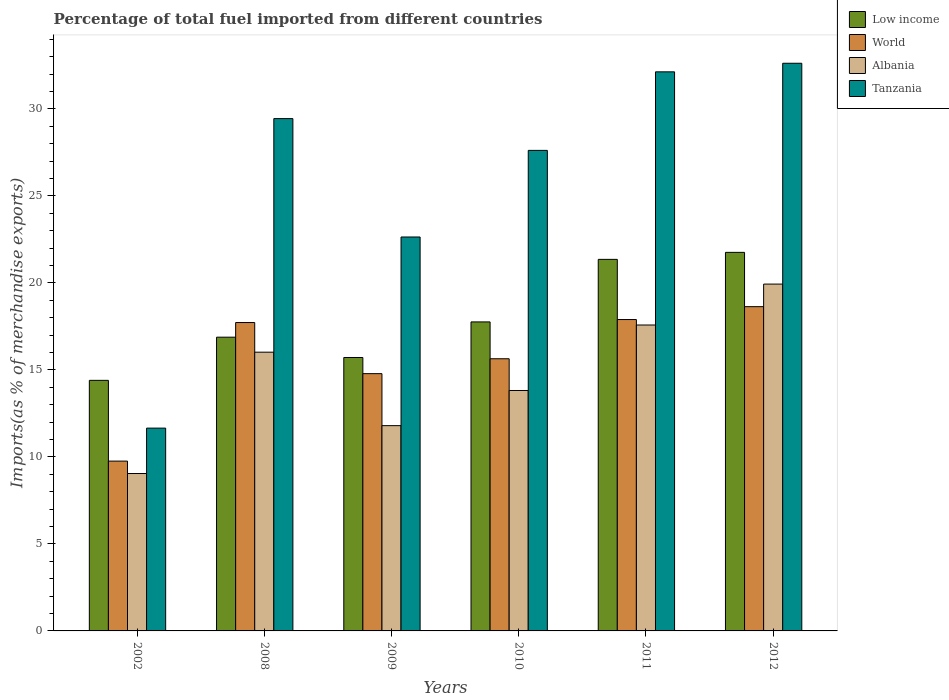How many groups of bars are there?
Your answer should be very brief. 6. In how many cases, is the number of bars for a given year not equal to the number of legend labels?
Your response must be concise. 0. What is the percentage of imports to different countries in Tanzania in 2012?
Offer a terse response. 32.63. Across all years, what is the maximum percentage of imports to different countries in Low income?
Your answer should be very brief. 21.76. Across all years, what is the minimum percentage of imports to different countries in Low income?
Make the answer very short. 14.4. In which year was the percentage of imports to different countries in Tanzania maximum?
Give a very brief answer. 2012. What is the total percentage of imports to different countries in Albania in the graph?
Provide a succinct answer. 88.2. What is the difference between the percentage of imports to different countries in Albania in 2002 and that in 2008?
Provide a short and direct response. -6.97. What is the difference between the percentage of imports to different countries in Tanzania in 2009 and the percentage of imports to different countries in Albania in 2002?
Keep it short and to the point. 13.6. What is the average percentage of imports to different countries in Low income per year?
Keep it short and to the point. 17.98. In the year 2002, what is the difference between the percentage of imports to different countries in Low income and percentage of imports to different countries in Albania?
Your response must be concise. 5.36. In how many years, is the percentage of imports to different countries in Albania greater than 27 %?
Your response must be concise. 0. What is the ratio of the percentage of imports to different countries in Tanzania in 2008 to that in 2009?
Offer a terse response. 1.3. Is the percentage of imports to different countries in Low income in 2002 less than that in 2008?
Provide a succinct answer. Yes. Is the difference between the percentage of imports to different countries in Low income in 2009 and 2010 greater than the difference between the percentage of imports to different countries in Albania in 2009 and 2010?
Ensure brevity in your answer.  No. What is the difference between the highest and the second highest percentage of imports to different countries in Low income?
Your response must be concise. 0.4. What is the difference between the highest and the lowest percentage of imports to different countries in Tanzania?
Give a very brief answer. 20.97. Is it the case that in every year, the sum of the percentage of imports to different countries in Low income and percentage of imports to different countries in Tanzania is greater than the sum of percentage of imports to different countries in Albania and percentage of imports to different countries in World?
Ensure brevity in your answer.  Yes. What does the 4th bar from the left in 2010 represents?
Your answer should be very brief. Tanzania. Is it the case that in every year, the sum of the percentage of imports to different countries in World and percentage of imports to different countries in Albania is greater than the percentage of imports to different countries in Low income?
Offer a terse response. Yes. How many years are there in the graph?
Give a very brief answer. 6. What is the difference between two consecutive major ticks on the Y-axis?
Give a very brief answer. 5. Are the values on the major ticks of Y-axis written in scientific E-notation?
Your answer should be very brief. No. Does the graph contain any zero values?
Offer a very short reply. No. Does the graph contain grids?
Give a very brief answer. No. How many legend labels are there?
Your answer should be very brief. 4. How are the legend labels stacked?
Ensure brevity in your answer.  Vertical. What is the title of the graph?
Provide a short and direct response. Percentage of total fuel imported from different countries. Does "World" appear as one of the legend labels in the graph?
Your response must be concise. Yes. What is the label or title of the Y-axis?
Your answer should be compact. Imports(as % of merchandise exports). What is the Imports(as % of merchandise exports) in Low income in 2002?
Ensure brevity in your answer.  14.4. What is the Imports(as % of merchandise exports) of World in 2002?
Your answer should be compact. 9.76. What is the Imports(as % of merchandise exports) of Albania in 2002?
Provide a succinct answer. 9.05. What is the Imports(as % of merchandise exports) in Tanzania in 2002?
Give a very brief answer. 11.66. What is the Imports(as % of merchandise exports) in Low income in 2008?
Your answer should be compact. 16.88. What is the Imports(as % of merchandise exports) in World in 2008?
Your response must be concise. 17.72. What is the Imports(as % of merchandise exports) of Albania in 2008?
Your answer should be very brief. 16.02. What is the Imports(as % of merchandise exports) of Tanzania in 2008?
Offer a terse response. 29.45. What is the Imports(as % of merchandise exports) in Low income in 2009?
Keep it short and to the point. 15.72. What is the Imports(as % of merchandise exports) in World in 2009?
Give a very brief answer. 14.79. What is the Imports(as % of merchandise exports) in Albania in 2009?
Your answer should be compact. 11.8. What is the Imports(as % of merchandise exports) in Tanzania in 2009?
Your response must be concise. 22.64. What is the Imports(as % of merchandise exports) in Low income in 2010?
Your response must be concise. 17.76. What is the Imports(as % of merchandise exports) of World in 2010?
Your answer should be compact. 15.64. What is the Imports(as % of merchandise exports) of Albania in 2010?
Provide a succinct answer. 13.82. What is the Imports(as % of merchandise exports) of Tanzania in 2010?
Your response must be concise. 27.62. What is the Imports(as % of merchandise exports) of Low income in 2011?
Keep it short and to the point. 21.36. What is the Imports(as % of merchandise exports) of World in 2011?
Offer a very short reply. 17.9. What is the Imports(as % of merchandise exports) in Albania in 2011?
Ensure brevity in your answer.  17.58. What is the Imports(as % of merchandise exports) of Tanzania in 2011?
Your answer should be very brief. 32.13. What is the Imports(as % of merchandise exports) in Low income in 2012?
Offer a terse response. 21.76. What is the Imports(as % of merchandise exports) in World in 2012?
Keep it short and to the point. 18.64. What is the Imports(as % of merchandise exports) in Albania in 2012?
Provide a succinct answer. 19.93. What is the Imports(as % of merchandise exports) in Tanzania in 2012?
Your response must be concise. 32.63. Across all years, what is the maximum Imports(as % of merchandise exports) of Low income?
Your response must be concise. 21.76. Across all years, what is the maximum Imports(as % of merchandise exports) in World?
Your answer should be very brief. 18.64. Across all years, what is the maximum Imports(as % of merchandise exports) of Albania?
Keep it short and to the point. 19.93. Across all years, what is the maximum Imports(as % of merchandise exports) of Tanzania?
Your answer should be very brief. 32.63. Across all years, what is the minimum Imports(as % of merchandise exports) of Low income?
Ensure brevity in your answer.  14.4. Across all years, what is the minimum Imports(as % of merchandise exports) of World?
Offer a terse response. 9.76. Across all years, what is the minimum Imports(as % of merchandise exports) in Albania?
Offer a very short reply. 9.05. Across all years, what is the minimum Imports(as % of merchandise exports) of Tanzania?
Provide a succinct answer. 11.66. What is the total Imports(as % of merchandise exports) of Low income in the graph?
Your response must be concise. 107.87. What is the total Imports(as % of merchandise exports) of World in the graph?
Keep it short and to the point. 94.45. What is the total Imports(as % of merchandise exports) in Albania in the graph?
Offer a terse response. 88.2. What is the total Imports(as % of merchandise exports) in Tanzania in the graph?
Your answer should be compact. 156.12. What is the difference between the Imports(as % of merchandise exports) of Low income in 2002 and that in 2008?
Provide a succinct answer. -2.48. What is the difference between the Imports(as % of merchandise exports) in World in 2002 and that in 2008?
Offer a terse response. -7.96. What is the difference between the Imports(as % of merchandise exports) in Albania in 2002 and that in 2008?
Ensure brevity in your answer.  -6.97. What is the difference between the Imports(as % of merchandise exports) of Tanzania in 2002 and that in 2008?
Keep it short and to the point. -17.79. What is the difference between the Imports(as % of merchandise exports) in Low income in 2002 and that in 2009?
Your response must be concise. -1.31. What is the difference between the Imports(as % of merchandise exports) of World in 2002 and that in 2009?
Your answer should be compact. -5.03. What is the difference between the Imports(as % of merchandise exports) in Albania in 2002 and that in 2009?
Your answer should be very brief. -2.75. What is the difference between the Imports(as % of merchandise exports) of Tanzania in 2002 and that in 2009?
Provide a succinct answer. -10.98. What is the difference between the Imports(as % of merchandise exports) in Low income in 2002 and that in 2010?
Your answer should be very brief. -3.36. What is the difference between the Imports(as % of merchandise exports) in World in 2002 and that in 2010?
Provide a succinct answer. -5.88. What is the difference between the Imports(as % of merchandise exports) in Albania in 2002 and that in 2010?
Offer a terse response. -4.77. What is the difference between the Imports(as % of merchandise exports) of Tanzania in 2002 and that in 2010?
Ensure brevity in your answer.  -15.96. What is the difference between the Imports(as % of merchandise exports) of Low income in 2002 and that in 2011?
Provide a succinct answer. -6.95. What is the difference between the Imports(as % of merchandise exports) in World in 2002 and that in 2011?
Your answer should be compact. -8.14. What is the difference between the Imports(as % of merchandise exports) of Albania in 2002 and that in 2011?
Make the answer very short. -8.54. What is the difference between the Imports(as % of merchandise exports) of Tanzania in 2002 and that in 2011?
Your answer should be very brief. -20.48. What is the difference between the Imports(as % of merchandise exports) in Low income in 2002 and that in 2012?
Your answer should be compact. -7.36. What is the difference between the Imports(as % of merchandise exports) in World in 2002 and that in 2012?
Provide a short and direct response. -8.88. What is the difference between the Imports(as % of merchandise exports) in Albania in 2002 and that in 2012?
Keep it short and to the point. -10.89. What is the difference between the Imports(as % of merchandise exports) of Tanzania in 2002 and that in 2012?
Provide a short and direct response. -20.97. What is the difference between the Imports(as % of merchandise exports) in Low income in 2008 and that in 2009?
Provide a short and direct response. 1.17. What is the difference between the Imports(as % of merchandise exports) of World in 2008 and that in 2009?
Give a very brief answer. 2.94. What is the difference between the Imports(as % of merchandise exports) in Albania in 2008 and that in 2009?
Keep it short and to the point. 4.22. What is the difference between the Imports(as % of merchandise exports) of Tanzania in 2008 and that in 2009?
Make the answer very short. 6.8. What is the difference between the Imports(as % of merchandise exports) of Low income in 2008 and that in 2010?
Make the answer very short. -0.88. What is the difference between the Imports(as % of merchandise exports) of World in 2008 and that in 2010?
Keep it short and to the point. 2.08. What is the difference between the Imports(as % of merchandise exports) of Albania in 2008 and that in 2010?
Offer a terse response. 2.2. What is the difference between the Imports(as % of merchandise exports) in Tanzania in 2008 and that in 2010?
Your response must be concise. 1.83. What is the difference between the Imports(as % of merchandise exports) of Low income in 2008 and that in 2011?
Your answer should be very brief. -4.47. What is the difference between the Imports(as % of merchandise exports) of World in 2008 and that in 2011?
Provide a succinct answer. -0.17. What is the difference between the Imports(as % of merchandise exports) of Albania in 2008 and that in 2011?
Your response must be concise. -1.56. What is the difference between the Imports(as % of merchandise exports) in Tanzania in 2008 and that in 2011?
Provide a short and direct response. -2.69. What is the difference between the Imports(as % of merchandise exports) of Low income in 2008 and that in 2012?
Give a very brief answer. -4.88. What is the difference between the Imports(as % of merchandise exports) of World in 2008 and that in 2012?
Offer a very short reply. -0.91. What is the difference between the Imports(as % of merchandise exports) in Albania in 2008 and that in 2012?
Provide a short and direct response. -3.91. What is the difference between the Imports(as % of merchandise exports) of Tanzania in 2008 and that in 2012?
Offer a very short reply. -3.18. What is the difference between the Imports(as % of merchandise exports) in Low income in 2009 and that in 2010?
Ensure brevity in your answer.  -2.04. What is the difference between the Imports(as % of merchandise exports) of World in 2009 and that in 2010?
Your response must be concise. -0.86. What is the difference between the Imports(as % of merchandise exports) in Albania in 2009 and that in 2010?
Give a very brief answer. -2.02. What is the difference between the Imports(as % of merchandise exports) in Tanzania in 2009 and that in 2010?
Provide a succinct answer. -4.98. What is the difference between the Imports(as % of merchandise exports) of Low income in 2009 and that in 2011?
Provide a short and direct response. -5.64. What is the difference between the Imports(as % of merchandise exports) in World in 2009 and that in 2011?
Keep it short and to the point. -3.11. What is the difference between the Imports(as % of merchandise exports) in Albania in 2009 and that in 2011?
Your answer should be compact. -5.78. What is the difference between the Imports(as % of merchandise exports) in Tanzania in 2009 and that in 2011?
Your answer should be compact. -9.49. What is the difference between the Imports(as % of merchandise exports) in Low income in 2009 and that in 2012?
Provide a short and direct response. -6.04. What is the difference between the Imports(as % of merchandise exports) in World in 2009 and that in 2012?
Ensure brevity in your answer.  -3.85. What is the difference between the Imports(as % of merchandise exports) in Albania in 2009 and that in 2012?
Provide a short and direct response. -8.14. What is the difference between the Imports(as % of merchandise exports) in Tanzania in 2009 and that in 2012?
Give a very brief answer. -9.99. What is the difference between the Imports(as % of merchandise exports) in Low income in 2010 and that in 2011?
Make the answer very short. -3.59. What is the difference between the Imports(as % of merchandise exports) in World in 2010 and that in 2011?
Make the answer very short. -2.25. What is the difference between the Imports(as % of merchandise exports) of Albania in 2010 and that in 2011?
Your response must be concise. -3.76. What is the difference between the Imports(as % of merchandise exports) in Tanzania in 2010 and that in 2011?
Ensure brevity in your answer.  -4.51. What is the difference between the Imports(as % of merchandise exports) in Low income in 2010 and that in 2012?
Offer a very short reply. -4. What is the difference between the Imports(as % of merchandise exports) of World in 2010 and that in 2012?
Ensure brevity in your answer.  -2.99. What is the difference between the Imports(as % of merchandise exports) of Albania in 2010 and that in 2012?
Your answer should be compact. -6.12. What is the difference between the Imports(as % of merchandise exports) in Tanzania in 2010 and that in 2012?
Give a very brief answer. -5.01. What is the difference between the Imports(as % of merchandise exports) of Low income in 2011 and that in 2012?
Keep it short and to the point. -0.4. What is the difference between the Imports(as % of merchandise exports) in World in 2011 and that in 2012?
Provide a short and direct response. -0.74. What is the difference between the Imports(as % of merchandise exports) in Albania in 2011 and that in 2012?
Keep it short and to the point. -2.35. What is the difference between the Imports(as % of merchandise exports) of Tanzania in 2011 and that in 2012?
Your answer should be very brief. -0.49. What is the difference between the Imports(as % of merchandise exports) of Low income in 2002 and the Imports(as % of merchandise exports) of World in 2008?
Provide a succinct answer. -3.32. What is the difference between the Imports(as % of merchandise exports) of Low income in 2002 and the Imports(as % of merchandise exports) of Albania in 2008?
Your answer should be compact. -1.62. What is the difference between the Imports(as % of merchandise exports) in Low income in 2002 and the Imports(as % of merchandise exports) in Tanzania in 2008?
Your answer should be very brief. -15.04. What is the difference between the Imports(as % of merchandise exports) of World in 2002 and the Imports(as % of merchandise exports) of Albania in 2008?
Provide a succinct answer. -6.26. What is the difference between the Imports(as % of merchandise exports) of World in 2002 and the Imports(as % of merchandise exports) of Tanzania in 2008?
Make the answer very short. -19.69. What is the difference between the Imports(as % of merchandise exports) in Albania in 2002 and the Imports(as % of merchandise exports) in Tanzania in 2008?
Offer a very short reply. -20.4. What is the difference between the Imports(as % of merchandise exports) in Low income in 2002 and the Imports(as % of merchandise exports) in World in 2009?
Make the answer very short. -0.38. What is the difference between the Imports(as % of merchandise exports) in Low income in 2002 and the Imports(as % of merchandise exports) in Albania in 2009?
Make the answer very short. 2.6. What is the difference between the Imports(as % of merchandise exports) of Low income in 2002 and the Imports(as % of merchandise exports) of Tanzania in 2009?
Make the answer very short. -8.24. What is the difference between the Imports(as % of merchandise exports) in World in 2002 and the Imports(as % of merchandise exports) in Albania in 2009?
Ensure brevity in your answer.  -2.04. What is the difference between the Imports(as % of merchandise exports) of World in 2002 and the Imports(as % of merchandise exports) of Tanzania in 2009?
Give a very brief answer. -12.88. What is the difference between the Imports(as % of merchandise exports) of Albania in 2002 and the Imports(as % of merchandise exports) of Tanzania in 2009?
Provide a succinct answer. -13.6. What is the difference between the Imports(as % of merchandise exports) of Low income in 2002 and the Imports(as % of merchandise exports) of World in 2010?
Provide a succinct answer. -1.24. What is the difference between the Imports(as % of merchandise exports) in Low income in 2002 and the Imports(as % of merchandise exports) in Albania in 2010?
Your answer should be very brief. 0.58. What is the difference between the Imports(as % of merchandise exports) in Low income in 2002 and the Imports(as % of merchandise exports) in Tanzania in 2010?
Make the answer very short. -13.22. What is the difference between the Imports(as % of merchandise exports) in World in 2002 and the Imports(as % of merchandise exports) in Albania in 2010?
Your response must be concise. -4.06. What is the difference between the Imports(as % of merchandise exports) in World in 2002 and the Imports(as % of merchandise exports) in Tanzania in 2010?
Make the answer very short. -17.86. What is the difference between the Imports(as % of merchandise exports) of Albania in 2002 and the Imports(as % of merchandise exports) of Tanzania in 2010?
Provide a succinct answer. -18.57. What is the difference between the Imports(as % of merchandise exports) in Low income in 2002 and the Imports(as % of merchandise exports) in World in 2011?
Offer a very short reply. -3.5. What is the difference between the Imports(as % of merchandise exports) of Low income in 2002 and the Imports(as % of merchandise exports) of Albania in 2011?
Offer a very short reply. -3.18. What is the difference between the Imports(as % of merchandise exports) in Low income in 2002 and the Imports(as % of merchandise exports) in Tanzania in 2011?
Ensure brevity in your answer.  -17.73. What is the difference between the Imports(as % of merchandise exports) of World in 2002 and the Imports(as % of merchandise exports) of Albania in 2011?
Offer a very short reply. -7.82. What is the difference between the Imports(as % of merchandise exports) of World in 2002 and the Imports(as % of merchandise exports) of Tanzania in 2011?
Make the answer very short. -22.37. What is the difference between the Imports(as % of merchandise exports) of Albania in 2002 and the Imports(as % of merchandise exports) of Tanzania in 2011?
Give a very brief answer. -23.09. What is the difference between the Imports(as % of merchandise exports) in Low income in 2002 and the Imports(as % of merchandise exports) in World in 2012?
Keep it short and to the point. -4.24. What is the difference between the Imports(as % of merchandise exports) of Low income in 2002 and the Imports(as % of merchandise exports) of Albania in 2012?
Provide a succinct answer. -5.53. What is the difference between the Imports(as % of merchandise exports) of Low income in 2002 and the Imports(as % of merchandise exports) of Tanzania in 2012?
Make the answer very short. -18.23. What is the difference between the Imports(as % of merchandise exports) in World in 2002 and the Imports(as % of merchandise exports) in Albania in 2012?
Ensure brevity in your answer.  -10.17. What is the difference between the Imports(as % of merchandise exports) of World in 2002 and the Imports(as % of merchandise exports) of Tanzania in 2012?
Provide a succinct answer. -22.87. What is the difference between the Imports(as % of merchandise exports) of Albania in 2002 and the Imports(as % of merchandise exports) of Tanzania in 2012?
Offer a terse response. -23.58. What is the difference between the Imports(as % of merchandise exports) in Low income in 2008 and the Imports(as % of merchandise exports) in World in 2009?
Provide a short and direct response. 2.1. What is the difference between the Imports(as % of merchandise exports) in Low income in 2008 and the Imports(as % of merchandise exports) in Albania in 2009?
Your answer should be very brief. 5.08. What is the difference between the Imports(as % of merchandise exports) of Low income in 2008 and the Imports(as % of merchandise exports) of Tanzania in 2009?
Provide a succinct answer. -5.76. What is the difference between the Imports(as % of merchandise exports) in World in 2008 and the Imports(as % of merchandise exports) in Albania in 2009?
Give a very brief answer. 5.93. What is the difference between the Imports(as % of merchandise exports) in World in 2008 and the Imports(as % of merchandise exports) in Tanzania in 2009?
Your response must be concise. -4.92. What is the difference between the Imports(as % of merchandise exports) in Albania in 2008 and the Imports(as % of merchandise exports) in Tanzania in 2009?
Your response must be concise. -6.62. What is the difference between the Imports(as % of merchandise exports) in Low income in 2008 and the Imports(as % of merchandise exports) in World in 2010?
Offer a very short reply. 1.24. What is the difference between the Imports(as % of merchandise exports) of Low income in 2008 and the Imports(as % of merchandise exports) of Albania in 2010?
Your answer should be very brief. 3.06. What is the difference between the Imports(as % of merchandise exports) of Low income in 2008 and the Imports(as % of merchandise exports) of Tanzania in 2010?
Offer a terse response. -10.74. What is the difference between the Imports(as % of merchandise exports) of World in 2008 and the Imports(as % of merchandise exports) of Albania in 2010?
Provide a succinct answer. 3.91. What is the difference between the Imports(as % of merchandise exports) of World in 2008 and the Imports(as % of merchandise exports) of Tanzania in 2010?
Keep it short and to the point. -9.9. What is the difference between the Imports(as % of merchandise exports) in Albania in 2008 and the Imports(as % of merchandise exports) in Tanzania in 2010?
Ensure brevity in your answer.  -11.6. What is the difference between the Imports(as % of merchandise exports) in Low income in 2008 and the Imports(as % of merchandise exports) in World in 2011?
Your response must be concise. -1.01. What is the difference between the Imports(as % of merchandise exports) in Low income in 2008 and the Imports(as % of merchandise exports) in Albania in 2011?
Offer a terse response. -0.7. What is the difference between the Imports(as % of merchandise exports) of Low income in 2008 and the Imports(as % of merchandise exports) of Tanzania in 2011?
Your answer should be compact. -15.25. What is the difference between the Imports(as % of merchandise exports) of World in 2008 and the Imports(as % of merchandise exports) of Albania in 2011?
Make the answer very short. 0.14. What is the difference between the Imports(as % of merchandise exports) in World in 2008 and the Imports(as % of merchandise exports) in Tanzania in 2011?
Your answer should be compact. -14.41. What is the difference between the Imports(as % of merchandise exports) of Albania in 2008 and the Imports(as % of merchandise exports) of Tanzania in 2011?
Provide a succinct answer. -16.11. What is the difference between the Imports(as % of merchandise exports) in Low income in 2008 and the Imports(as % of merchandise exports) in World in 2012?
Ensure brevity in your answer.  -1.75. What is the difference between the Imports(as % of merchandise exports) of Low income in 2008 and the Imports(as % of merchandise exports) of Albania in 2012?
Your answer should be compact. -3.05. What is the difference between the Imports(as % of merchandise exports) of Low income in 2008 and the Imports(as % of merchandise exports) of Tanzania in 2012?
Provide a short and direct response. -15.74. What is the difference between the Imports(as % of merchandise exports) in World in 2008 and the Imports(as % of merchandise exports) in Albania in 2012?
Give a very brief answer. -2.21. What is the difference between the Imports(as % of merchandise exports) of World in 2008 and the Imports(as % of merchandise exports) of Tanzania in 2012?
Offer a terse response. -14.9. What is the difference between the Imports(as % of merchandise exports) of Albania in 2008 and the Imports(as % of merchandise exports) of Tanzania in 2012?
Your answer should be compact. -16.61. What is the difference between the Imports(as % of merchandise exports) of Low income in 2009 and the Imports(as % of merchandise exports) of World in 2010?
Your answer should be compact. 0.07. What is the difference between the Imports(as % of merchandise exports) of Low income in 2009 and the Imports(as % of merchandise exports) of Albania in 2010?
Make the answer very short. 1.9. What is the difference between the Imports(as % of merchandise exports) of Low income in 2009 and the Imports(as % of merchandise exports) of Tanzania in 2010?
Your answer should be compact. -11.9. What is the difference between the Imports(as % of merchandise exports) in World in 2009 and the Imports(as % of merchandise exports) in Albania in 2010?
Your answer should be compact. 0.97. What is the difference between the Imports(as % of merchandise exports) of World in 2009 and the Imports(as % of merchandise exports) of Tanzania in 2010?
Offer a terse response. -12.83. What is the difference between the Imports(as % of merchandise exports) of Albania in 2009 and the Imports(as % of merchandise exports) of Tanzania in 2010?
Provide a succinct answer. -15.82. What is the difference between the Imports(as % of merchandise exports) in Low income in 2009 and the Imports(as % of merchandise exports) in World in 2011?
Offer a terse response. -2.18. What is the difference between the Imports(as % of merchandise exports) in Low income in 2009 and the Imports(as % of merchandise exports) in Albania in 2011?
Your answer should be compact. -1.87. What is the difference between the Imports(as % of merchandise exports) in Low income in 2009 and the Imports(as % of merchandise exports) in Tanzania in 2011?
Provide a succinct answer. -16.42. What is the difference between the Imports(as % of merchandise exports) in World in 2009 and the Imports(as % of merchandise exports) in Albania in 2011?
Provide a succinct answer. -2.8. What is the difference between the Imports(as % of merchandise exports) in World in 2009 and the Imports(as % of merchandise exports) in Tanzania in 2011?
Keep it short and to the point. -17.35. What is the difference between the Imports(as % of merchandise exports) of Albania in 2009 and the Imports(as % of merchandise exports) of Tanzania in 2011?
Make the answer very short. -20.34. What is the difference between the Imports(as % of merchandise exports) of Low income in 2009 and the Imports(as % of merchandise exports) of World in 2012?
Give a very brief answer. -2.92. What is the difference between the Imports(as % of merchandise exports) of Low income in 2009 and the Imports(as % of merchandise exports) of Albania in 2012?
Your response must be concise. -4.22. What is the difference between the Imports(as % of merchandise exports) in Low income in 2009 and the Imports(as % of merchandise exports) in Tanzania in 2012?
Provide a succinct answer. -16.91. What is the difference between the Imports(as % of merchandise exports) in World in 2009 and the Imports(as % of merchandise exports) in Albania in 2012?
Offer a terse response. -5.15. What is the difference between the Imports(as % of merchandise exports) of World in 2009 and the Imports(as % of merchandise exports) of Tanzania in 2012?
Make the answer very short. -17.84. What is the difference between the Imports(as % of merchandise exports) in Albania in 2009 and the Imports(as % of merchandise exports) in Tanzania in 2012?
Provide a short and direct response. -20.83. What is the difference between the Imports(as % of merchandise exports) in Low income in 2010 and the Imports(as % of merchandise exports) in World in 2011?
Offer a very short reply. -0.14. What is the difference between the Imports(as % of merchandise exports) in Low income in 2010 and the Imports(as % of merchandise exports) in Albania in 2011?
Make the answer very short. 0.18. What is the difference between the Imports(as % of merchandise exports) in Low income in 2010 and the Imports(as % of merchandise exports) in Tanzania in 2011?
Provide a short and direct response. -14.37. What is the difference between the Imports(as % of merchandise exports) in World in 2010 and the Imports(as % of merchandise exports) in Albania in 2011?
Make the answer very short. -1.94. What is the difference between the Imports(as % of merchandise exports) in World in 2010 and the Imports(as % of merchandise exports) in Tanzania in 2011?
Provide a short and direct response. -16.49. What is the difference between the Imports(as % of merchandise exports) in Albania in 2010 and the Imports(as % of merchandise exports) in Tanzania in 2011?
Give a very brief answer. -18.31. What is the difference between the Imports(as % of merchandise exports) in Low income in 2010 and the Imports(as % of merchandise exports) in World in 2012?
Offer a terse response. -0.88. What is the difference between the Imports(as % of merchandise exports) of Low income in 2010 and the Imports(as % of merchandise exports) of Albania in 2012?
Provide a short and direct response. -2.17. What is the difference between the Imports(as % of merchandise exports) in Low income in 2010 and the Imports(as % of merchandise exports) in Tanzania in 2012?
Keep it short and to the point. -14.87. What is the difference between the Imports(as % of merchandise exports) in World in 2010 and the Imports(as % of merchandise exports) in Albania in 2012?
Your response must be concise. -4.29. What is the difference between the Imports(as % of merchandise exports) in World in 2010 and the Imports(as % of merchandise exports) in Tanzania in 2012?
Ensure brevity in your answer.  -16.98. What is the difference between the Imports(as % of merchandise exports) of Albania in 2010 and the Imports(as % of merchandise exports) of Tanzania in 2012?
Make the answer very short. -18.81. What is the difference between the Imports(as % of merchandise exports) of Low income in 2011 and the Imports(as % of merchandise exports) of World in 2012?
Make the answer very short. 2.72. What is the difference between the Imports(as % of merchandise exports) of Low income in 2011 and the Imports(as % of merchandise exports) of Albania in 2012?
Offer a terse response. 1.42. What is the difference between the Imports(as % of merchandise exports) of Low income in 2011 and the Imports(as % of merchandise exports) of Tanzania in 2012?
Offer a terse response. -11.27. What is the difference between the Imports(as % of merchandise exports) in World in 2011 and the Imports(as % of merchandise exports) in Albania in 2012?
Your response must be concise. -2.04. What is the difference between the Imports(as % of merchandise exports) in World in 2011 and the Imports(as % of merchandise exports) in Tanzania in 2012?
Give a very brief answer. -14.73. What is the difference between the Imports(as % of merchandise exports) of Albania in 2011 and the Imports(as % of merchandise exports) of Tanzania in 2012?
Give a very brief answer. -15.04. What is the average Imports(as % of merchandise exports) of Low income per year?
Make the answer very short. 17.98. What is the average Imports(as % of merchandise exports) of World per year?
Provide a short and direct response. 15.74. What is the average Imports(as % of merchandise exports) of Albania per year?
Make the answer very short. 14.7. What is the average Imports(as % of merchandise exports) in Tanzania per year?
Provide a succinct answer. 26.02. In the year 2002, what is the difference between the Imports(as % of merchandise exports) in Low income and Imports(as % of merchandise exports) in World?
Provide a short and direct response. 4.64. In the year 2002, what is the difference between the Imports(as % of merchandise exports) of Low income and Imports(as % of merchandise exports) of Albania?
Give a very brief answer. 5.36. In the year 2002, what is the difference between the Imports(as % of merchandise exports) in Low income and Imports(as % of merchandise exports) in Tanzania?
Give a very brief answer. 2.75. In the year 2002, what is the difference between the Imports(as % of merchandise exports) in World and Imports(as % of merchandise exports) in Albania?
Offer a terse response. 0.71. In the year 2002, what is the difference between the Imports(as % of merchandise exports) in World and Imports(as % of merchandise exports) in Tanzania?
Give a very brief answer. -1.9. In the year 2002, what is the difference between the Imports(as % of merchandise exports) of Albania and Imports(as % of merchandise exports) of Tanzania?
Your answer should be very brief. -2.61. In the year 2008, what is the difference between the Imports(as % of merchandise exports) of Low income and Imports(as % of merchandise exports) of World?
Provide a succinct answer. -0.84. In the year 2008, what is the difference between the Imports(as % of merchandise exports) of Low income and Imports(as % of merchandise exports) of Albania?
Keep it short and to the point. 0.86. In the year 2008, what is the difference between the Imports(as % of merchandise exports) of Low income and Imports(as % of merchandise exports) of Tanzania?
Your response must be concise. -12.56. In the year 2008, what is the difference between the Imports(as % of merchandise exports) of World and Imports(as % of merchandise exports) of Albania?
Give a very brief answer. 1.7. In the year 2008, what is the difference between the Imports(as % of merchandise exports) of World and Imports(as % of merchandise exports) of Tanzania?
Offer a terse response. -11.72. In the year 2008, what is the difference between the Imports(as % of merchandise exports) of Albania and Imports(as % of merchandise exports) of Tanzania?
Keep it short and to the point. -13.42. In the year 2009, what is the difference between the Imports(as % of merchandise exports) in Low income and Imports(as % of merchandise exports) in World?
Give a very brief answer. 0.93. In the year 2009, what is the difference between the Imports(as % of merchandise exports) of Low income and Imports(as % of merchandise exports) of Albania?
Make the answer very short. 3.92. In the year 2009, what is the difference between the Imports(as % of merchandise exports) in Low income and Imports(as % of merchandise exports) in Tanzania?
Make the answer very short. -6.93. In the year 2009, what is the difference between the Imports(as % of merchandise exports) in World and Imports(as % of merchandise exports) in Albania?
Ensure brevity in your answer.  2.99. In the year 2009, what is the difference between the Imports(as % of merchandise exports) of World and Imports(as % of merchandise exports) of Tanzania?
Ensure brevity in your answer.  -7.85. In the year 2009, what is the difference between the Imports(as % of merchandise exports) in Albania and Imports(as % of merchandise exports) in Tanzania?
Give a very brief answer. -10.84. In the year 2010, what is the difference between the Imports(as % of merchandise exports) in Low income and Imports(as % of merchandise exports) in World?
Give a very brief answer. 2.12. In the year 2010, what is the difference between the Imports(as % of merchandise exports) of Low income and Imports(as % of merchandise exports) of Albania?
Your answer should be very brief. 3.94. In the year 2010, what is the difference between the Imports(as % of merchandise exports) in Low income and Imports(as % of merchandise exports) in Tanzania?
Provide a short and direct response. -9.86. In the year 2010, what is the difference between the Imports(as % of merchandise exports) in World and Imports(as % of merchandise exports) in Albania?
Give a very brief answer. 1.82. In the year 2010, what is the difference between the Imports(as % of merchandise exports) in World and Imports(as % of merchandise exports) in Tanzania?
Your answer should be very brief. -11.98. In the year 2010, what is the difference between the Imports(as % of merchandise exports) in Albania and Imports(as % of merchandise exports) in Tanzania?
Make the answer very short. -13.8. In the year 2011, what is the difference between the Imports(as % of merchandise exports) in Low income and Imports(as % of merchandise exports) in World?
Make the answer very short. 3.46. In the year 2011, what is the difference between the Imports(as % of merchandise exports) of Low income and Imports(as % of merchandise exports) of Albania?
Offer a very short reply. 3.77. In the year 2011, what is the difference between the Imports(as % of merchandise exports) of Low income and Imports(as % of merchandise exports) of Tanzania?
Your answer should be very brief. -10.78. In the year 2011, what is the difference between the Imports(as % of merchandise exports) of World and Imports(as % of merchandise exports) of Albania?
Give a very brief answer. 0.31. In the year 2011, what is the difference between the Imports(as % of merchandise exports) in World and Imports(as % of merchandise exports) in Tanzania?
Provide a short and direct response. -14.24. In the year 2011, what is the difference between the Imports(as % of merchandise exports) in Albania and Imports(as % of merchandise exports) in Tanzania?
Provide a short and direct response. -14.55. In the year 2012, what is the difference between the Imports(as % of merchandise exports) of Low income and Imports(as % of merchandise exports) of World?
Offer a very short reply. 3.12. In the year 2012, what is the difference between the Imports(as % of merchandise exports) of Low income and Imports(as % of merchandise exports) of Albania?
Offer a very short reply. 1.82. In the year 2012, what is the difference between the Imports(as % of merchandise exports) of Low income and Imports(as % of merchandise exports) of Tanzania?
Ensure brevity in your answer.  -10.87. In the year 2012, what is the difference between the Imports(as % of merchandise exports) in World and Imports(as % of merchandise exports) in Albania?
Offer a terse response. -1.3. In the year 2012, what is the difference between the Imports(as % of merchandise exports) of World and Imports(as % of merchandise exports) of Tanzania?
Offer a very short reply. -13.99. In the year 2012, what is the difference between the Imports(as % of merchandise exports) of Albania and Imports(as % of merchandise exports) of Tanzania?
Your answer should be compact. -12.69. What is the ratio of the Imports(as % of merchandise exports) of Low income in 2002 to that in 2008?
Offer a very short reply. 0.85. What is the ratio of the Imports(as % of merchandise exports) of World in 2002 to that in 2008?
Give a very brief answer. 0.55. What is the ratio of the Imports(as % of merchandise exports) of Albania in 2002 to that in 2008?
Offer a very short reply. 0.56. What is the ratio of the Imports(as % of merchandise exports) in Tanzania in 2002 to that in 2008?
Your response must be concise. 0.4. What is the ratio of the Imports(as % of merchandise exports) in Low income in 2002 to that in 2009?
Your answer should be compact. 0.92. What is the ratio of the Imports(as % of merchandise exports) of World in 2002 to that in 2009?
Provide a short and direct response. 0.66. What is the ratio of the Imports(as % of merchandise exports) in Albania in 2002 to that in 2009?
Make the answer very short. 0.77. What is the ratio of the Imports(as % of merchandise exports) of Tanzania in 2002 to that in 2009?
Offer a terse response. 0.51. What is the ratio of the Imports(as % of merchandise exports) in Low income in 2002 to that in 2010?
Provide a short and direct response. 0.81. What is the ratio of the Imports(as % of merchandise exports) in World in 2002 to that in 2010?
Make the answer very short. 0.62. What is the ratio of the Imports(as % of merchandise exports) of Albania in 2002 to that in 2010?
Provide a short and direct response. 0.65. What is the ratio of the Imports(as % of merchandise exports) in Tanzania in 2002 to that in 2010?
Ensure brevity in your answer.  0.42. What is the ratio of the Imports(as % of merchandise exports) in Low income in 2002 to that in 2011?
Provide a short and direct response. 0.67. What is the ratio of the Imports(as % of merchandise exports) of World in 2002 to that in 2011?
Your response must be concise. 0.55. What is the ratio of the Imports(as % of merchandise exports) of Albania in 2002 to that in 2011?
Offer a very short reply. 0.51. What is the ratio of the Imports(as % of merchandise exports) of Tanzania in 2002 to that in 2011?
Your answer should be very brief. 0.36. What is the ratio of the Imports(as % of merchandise exports) in Low income in 2002 to that in 2012?
Keep it short and to the point. 0.66. What is the ratio of the Imports(as % of merchandise exports) in World in 2002 to that in 2012?
Ensure brevity in your answer.  0.52. What is the ratio of the Imports(as % of merchandise exports) in Albania in 2002 to that in 2012?
Give a very brief answer. 0.45. What is the ratio of the Imports(as % of merchandise exports) of Tanzania in 2002 to that in 2012?
Offer a terse response. 0.36. What is the ratio of the Imports(as % of merchandise exports) of Low income in 2008 to that in 2009?
Your answer should be compact. 1.07. What is the ratio of the Imports(as % of merchandise exports) of World in 2008 to that in 2009?
Ensure brevity in your answer.  1.2. What is the ratio of the Imports(as % of merchandise exports) in Albania in 2008 to that in 2009?
Your answer should be very brief. 1.36. What is the ratio of the Imports(as % of merchandise exports) of Tanzania in 2008 to that in 2009?
Offer a very short reply. 1.3. What is the ratio of the Imports(as % of merchandise exports) of Low income in 2008 to that in 2010?
Give a very brief answer. 0.95. What is the ratio of the Imports(as % of merchandise exports) in World in 2008 to that in 2010?
Give a very brief answer. 1.13. What is the ratio of the Imports(as % of merchandise exports) in Albania in 2008 to that in 2010?
Keep it short and to the point. 1.16. What is the ratio of the Imports(as % of merchandise exports) of Tanzania in 2008 to that in 2010?
Your answer should be very brief. 1.07. What is the ratio of the Imports(as % of merchandise exports) of Low income in 2008 to that in 2011?
Your response must be concise. 0.79. What is the ratio of the Imports(as % of merchandise exports) of World in 2008 to that in 2011?
Keep it short and to the point. 0.99. What is the ratio of the Imports(as % of merchandise exports) of Albania in 2008 to that in 2011?
Ensure brevity in your answer.  0.91. What is the ratio of the Imports(as % of merchandise exports) in Tanzania in 2008 to that in 2011?
Offer a terse response. 0.92. What is the ratio of the Imports(as % of merchandise exports) of Low income in 2008 to that in 2012?
Your answer should be compact. 0.78. What is the ratio of the Imports(as % of merchandise exports) of World in 2008 to that in 2012?
Offer a terse response. 0.95. What is the ratio of the Imports(as % of merchandise exports) of Albania in 2008 to that in 2012?
Provide a succinct answer. 0.8. What is the ratio of the Imports(as % of merchandise exports) of Tanzania in 2008 to that in 2012?
Offer a very short reply. 0.9. What is the ratio of the Imports(as % of merchandise exports) of Low income in 2009 to that in 2010?
Offer a terse response. 0.88. What is the ratio of the Imports(as % of merchandise exports) in World in 2009 to that in 2010?
Your response must be concise. 0.95. What is the ratio of the Imports(as % of merchandise exports) in Albania in 2009 to that in 2010?
Provide a short and direct response. 0.85. What is the ratio of the Imports(as % of merchandise exports) in Tanzania in 2009 to that in 2010?
Provide a short and direct response. 0.82. What is the ratio of the Imports(as % of merchandise exports) of Low income in 2009 to that in 2011?
Keep it short and to the point. 0.74. What is the ratio of the Imports(as % of merchandise exports) in World in 2009 to that in 2011?
Ensure brevity in your answer.  0.83. What is the ratio of the Imports(as % of merchandise exports) of Albania in 2009 to that in 2011?
Offer a very short reply. 0.67. What is the ratio of the Imports(as % of merchandise exports) in Tanzania in 2009 to that in 2011?
Your answer should be very brief. 0.7. What is the ratio of the Imports(as % of merchandise exports) of Low income in 2009 to that in 2012?
Make the answer very short. 0.72. What is the ratio of the Imports(as % of merchandise exports) in World in 2009 to that in 2012?
Provide a succinct answer. 0.79. What is the ratio of the Imports(as % of merchandise exports) in Albania in 2009 to that in 2012?
Your answer should be compact. 0.59. What is the ratio of the Imports(as % of merchandise exports) of Tanzania in 2009 to that in 2012?
Give a very brief answer. 0.69. What is the ratio of the Imports(as % of merchandise exports) of Low income in 2010 to that in 2011?
Your response must be concise. 0.83. What is the ratio of the Imports(as % of merchandise exports) in World in 2010 to that in 2011?
Your answer should be very brief. 0.87. What is the ratio of the Imports(as % of merchandise exports) in Albania in 2010 to that in 2011?
Your answer should be compact. 0.79. What is the ratio of the Imports(as % of merchandise exports) of Tanzania in 2010 to that in 2011?
Offer a terse response. 0.86. What is the ratio of the Imports(as % of merchandise exports) in Low income in 2010 to that in 2012?
Keep it short and to the point. 0.82. What is the ratio of the Imports(as % of merchandise exports) in World in 2010 to that in 2012?
Provide a short and direct response. 0.84. What is the ratio of the Imports(as % of merchandise exports) of Albania in 2010 to that in 2012?
Your answer should be compact. 0.69. What is the ratio of the Imports(as % of merchandise exports) of Tanzania in 2010 to that in 2012?
Give a very brief answer. 0.85. What is the ratio of the Imports(as % of merchandise exports) of Low income in 2011 to that in 2012?
Keep it short and to the point. 0.98. What is the ratio of the Imports(as % of merchandise exports) of World in 2011 to that in 2012?
Offer a terse response. 0.96. What is the ratio of the Imports(as % of merchandise exports) of Albania in 2011 to that in 2012?
Your answer should be very brief. 0.88. What is the ratio of the Imports(as % of merchandise exports) in Tanzania in 2011 to that in 2012?
Your answer should be very brief. 0.98. What is the difference between the highest and the second highest Imports(as % of merchandise exports) in Low income?
Provide a succinct answer. 0.4. What is the difference between the highest and the second highest Imports(as % of merchandise exports) of World?
Provide a short and direct response. 0.74. What is the difference between the highest and the second highest Imports(as % of merchandise exports) in Albania?
Give a very brief answer. 2.35. What is the difference between the highest and the second highest Imports(as % of merchandise exports) in Tanzania?
Make the answer very short. 0.49. What is the difference between the highest and the lowest Imports(as % of merchandise exports) in Low income?
Provide a short and direct response. 7.36. What is the difference between the highest and the lowest Imports(as % of merchandise exports) of World?
Provide a short and direct response. 8.88. What is the difference between the highest and the lowest Imports(as % of merchandise exports) of Albania?
Your answer should be compact. 10.89. What is the difference between the highest and the lowest Imports(as % of merchandise exports) in Tanzania?
Offer a very short reply. 20.97. 